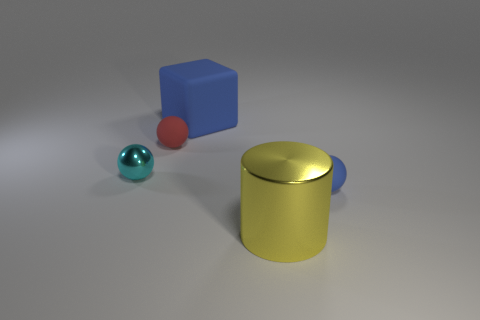What materials do the objects in the image appear to be made of? The objects seem to have different materials. The blue cube looks like it could be made of a matte plastic, the red sphere seems to have a slightly reflective surface which could suggest a polished wooden or plastic material, and the yellow cylinder appears to have a metallic finish, giving it a somewhat shiny appearance. 